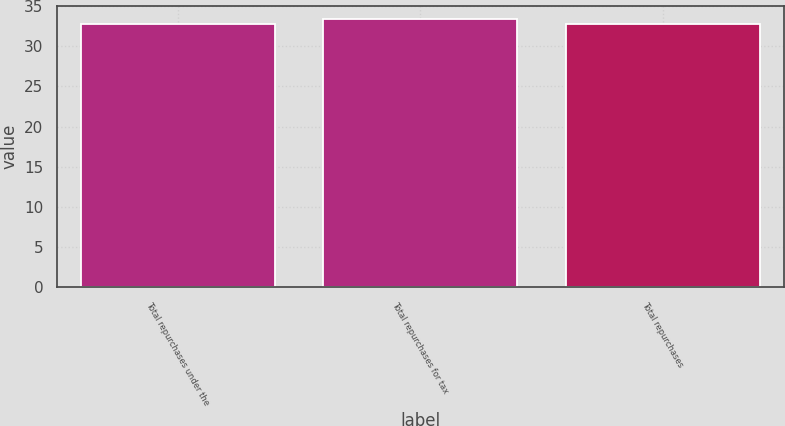<chart> <loc_0><loc_0><loc_500><loc_500><bar_chart><fcel>Total repurchases under the<fcel>Total repurchases for tax<fcel>Total repurchases<nl><fcel>32.76<fcel>33.37<fcel>32.82<nl></chart> 